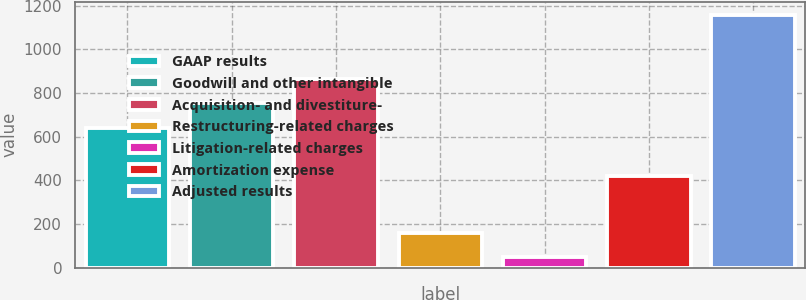Convert chart to OTSL. <chart><loc_0><loc_0><loc_500><loc_500><bar_chart><fcel>GAAP results<fcel>Goodwill and other intangible<fcel>Acquisition- and divestiture-<fcel>Restructuring-related charges<fcel>Litigation-related charges<fcel>Amortization expense<fcel>Adjusted results<nl><fcel>642<fcel>753.2<fcel>864.4<fcel>159.2<fcel>48<fcel>421<fcel>1160<nl></chart> 